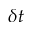Convert formula to latex. <formula><loc_0><loc_0><loc_500><loc_500>\delta t</formula> 